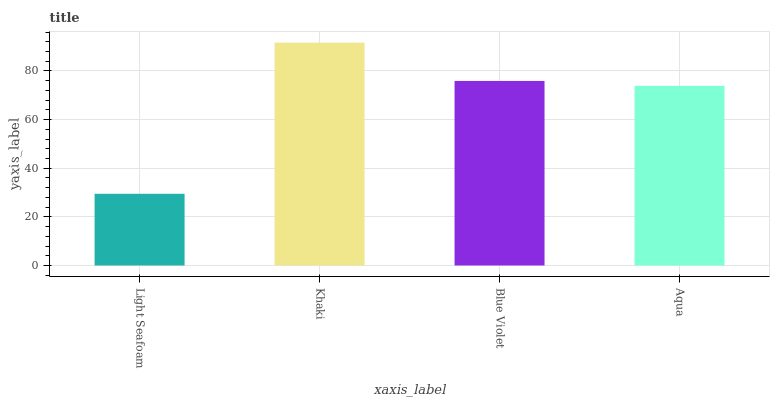Is Blue Violet the minimum?
Answer yes or no. No. Is Blue Violet the maximum?
Answer yes or no. No. Is Khaki greater than Blue Violet?
Answer yes or no. Yes. Is Blue Violet less than Khaki?
Answer yes or no. Yes. Is Blue Violet greater than Khaki?
Answer yes or no. No. Is Khaki less than Blue Violet?
Answer yes or no. No. Is Blue Violet the high median?
Answer yes or no. Yes. Is Aqua the low median?
Answer yes or no. Yes. Is Khaki the high median?
Answer yes or no. No. Is Light Seafoam the low median?
Answer yes or no. No. 